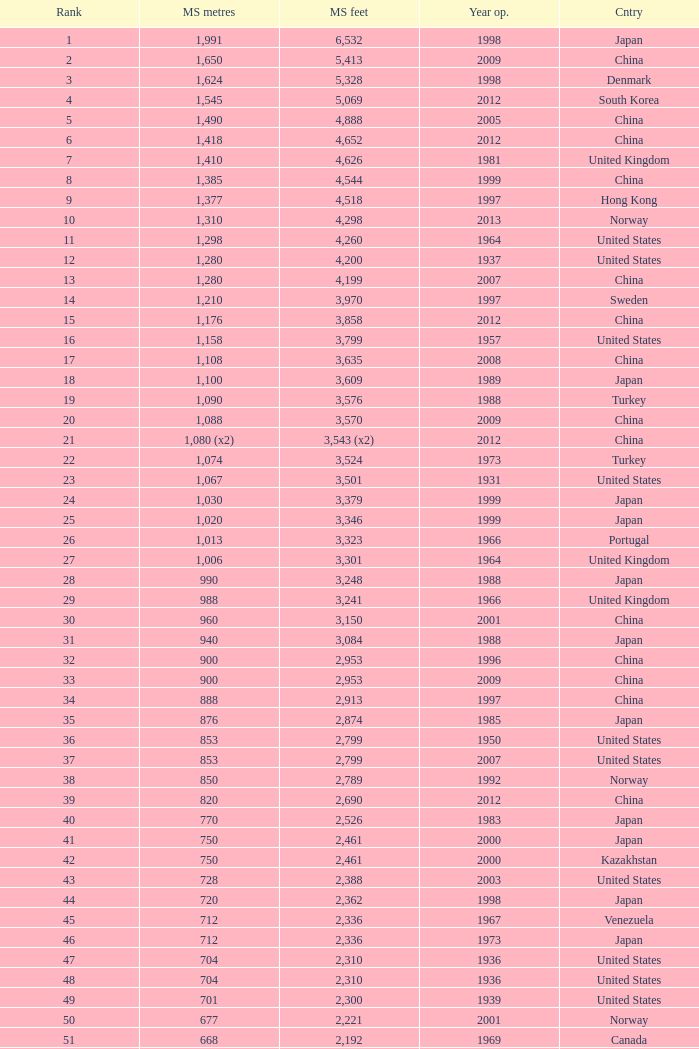In south korea, what is the oldest year that has a central span measuring 1,640 feet? 2002.0. 